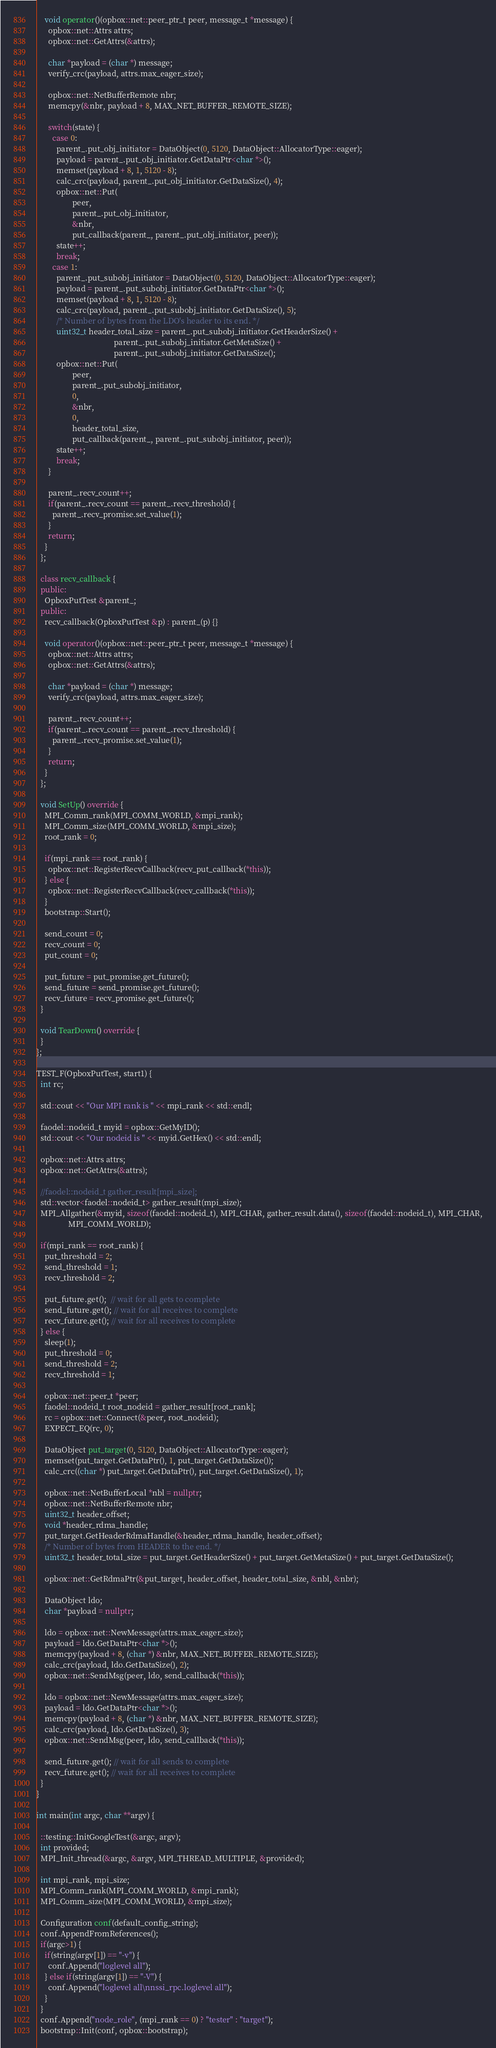<code> <loc_0><loc_0><loc_500><loc_500><_C++_>
    void operator()(opbox::net::peer_ptr_t peer, message_t *message) {
      opbox::net::Attrs attrs;
      opbox::net::GetAttrs(&attrs);

      char *payload = (char *) message;
      verify_crc(payload, attrs.max_eager_size);

      opbox::net::NetBufferRemote nbr;
      memcpy(&nbr, payload + 8, MAX_NET_BUFFER_REMOTE_SIZE);

      switch(state) {
        case 0:
          parent_.put_obj_initiator = DataObject(0, 5120, DataObject::AllocatorType::eager);
          payload = parent_.put_obj_initiator.GetDataPtr<char *>();
          memset(payload + 8, 1, 5120 - 8);
          calc_crc(payload, parent_.put_obj_initiator.GetDataSize(), 4);
          opbox::net::Put(
                  peer,
                  parent_.put_obj_initiator,
                  &nbr,
                  put_callback(parent_, parent_.put_obj_initiator, peer));
          state++;
          break;
        case 1:
          parent_.put_subobj_initiator = DataObject(0, 5120, DataObject::AllocatorType::eager);
          payload = parent_.put_subobj_initiator.GetDataPtr<char *>();
          memset(payload + 8, 1, 5120 - 8);
          calc_crc(payload, parent_.put_subobj_initiator.GetDataSize(), 5);
          /* Number of bytes from the LDO's header to its end. */
          uint32_t header_total_size = parent_.put_subobj_initiator.GetHeaderSize() +
                                       parent_.put_subobj_initiator.GetMetaSize() +
                                       parent_.put_subobj_initiator.GetDataSize();
          opbox::net::Put(
                  peer,
                  parent_.put_subobj_initiator,
                  0,
                  &nbr,
                  0,
                  header_total_size,
                  put_callback(parent_, parent_.put_subobj_initiator, peer));
          state++;
          break;
      }

      parent_.recv_count++;
      if(parent_.recv_count == parent_.recv_threshold) {
        parent_.recv_promise.set_value(1);
      }
      return;
    }
  };

  class recv_callback {
  public:
    OpboxPutTest &parent_;
  public:
    recv_callback(OpboxPutTest &p) : parent_(p) {}

    void operator()(opbox::net::peer_ptr_t peer, message_t *message) {
      opbox::net::Attrs attrs;
      opbox::net::GetAttrs(&attrs);

      char *payload = (char *) message;
      verify_crc(payload, attrs.max_eager_size);

      parent_.recv_count++;
      if(parent_.recv_count == parent_.recv_threshold) {
        parent_.recv_promise.set_value(1);
      }
      return;
    }
  };

  void SetUp() override {
    MPI_Comm_rank(MPI_COMM_WORLD, &mpi_rank);
    MPI_Comm_size(MPI_COMM_WORLD, &mpi_size);
    root_rank = 0;

    if(mpi_rank == root_rank) {
      opbox::net::RegisterRecvCallback(recv_put_callback(*this));
    } else {
      opbox::net::RegisterRecvCallback(recv_callback(*this));
    }
    bootstrap::Start();

    send_count = 0;
    recv_count = 0;
    put_count = 0;

    put_future = put_promise.get_future();
    send_future = send_promise.get_future();
    recv_future = recv_promise.get_future();
  }

  void TearDown() override {
  }
};

TEST_F(OpboxPutTest, start1) {
  int rc;

  std::cout << "Our MPI rank is " << mpi_rank << std::endl;

  faodel::nodeid_t myid = opbox::GetMyID();
  std::cout << "Our nodeid is " << myid.GetHex() << std::endl;

  opbox::net::Attrs attrs;
  opbox::net::GetAttrs(&attrs);

  //faodel::nodeid_t gather_result[mpi_size];
  std::vector<faodel::nodeid_t> gather_result(mpi_size);
  MPI_Allgather(&myid, sizeof(faodel::nodeid_t), MPI_CHAR, gather_result.data(), sizeof(faodel::nodeid_t), MPI_CHAR,
                MPI_COMM_WORLD);

  if(mpi_rank == root_rank) {
    put_threshold = 2;
    send_threshold = 1;
    recv_threshold = 2;

    put_future.get();  // wait for all gets to complete
    send_future.get(); // wait for all receives to complete
    recv_future.get(); // wait for all receives to complete
  } else {
    sleep(1);
    put_threshold = 0;
    send_threshold = 2;
    recv_threshold = 1;

    opbox::net::peer_t *peer;
    faodel::nodeid_t root_nodeid = gather_result[root_rank];
    rc = opbox::net::Connect(&peer, root_nodeid);
    EXPECT_EQ(rc, 0);

    DataObject put_target(0, 5120, DataObject::AllocatorType::eager);
    memset(put_target.GetDataPtr(), 1, put_target.GetDataSize());
    calc_crc((char *) put_target.GetDataPtr(), put_target.GetDataSize(), 1);

    opbox::net::NetBufferLocal *nbl = nullptr;
    opbox::net::NetBufferRemote nbr;
    uint32_t header_offset;
    void *header_rdma_handle;
    put_target.GetHeaderRdmaHandle(&header_rdma_handle, header_offset);
    /* Number of bytes from HEADER to the end. */
    uint32_t header_total_size = put_target.GetHeaderSize() + put_target.GetMetaSize() + put_target.GetDataSize();

    opbox::net::GetRdmaPtr(&put_target, header_offset, header_total_size, &nbl, &nbr);

    DataObject ldo;
    char *payload = nullptr;

    ldo = opbox::net::NewMessage(attrs.max_eager_size);
    payload = ldo.GetDataPtr<char *>();
    memcpy(payload + 8, (char *) &nbr, MAX_NET_BUFFER_REMOTE_SIZE);
    calc_crc(payload, ldo.GetDataSize(), 2);
    opbox::net::SendMsg(peer, ldo, send_callback(*this));

    ldo = opbox::net::NewMessage(attrs.max_eager_size);
    payload = ldo.GetDataPtr<char *>();
    memcpy(payload + 8, (char *) &nbr, MAX_NET_BUFFER_REMOTE_SIZE);
    calc_crc(payload, ldo.GetDataSize(), 3);
    opbox::net::SendMsg(peer, ldo, send_callback(*this));

    send_future.get(); // wait for all sends to complete
    recv_future.get(); // wait for all receives to complete
  }
}

int main(int argc, char **argv) {

  ::testing::InitGoogleTest(&argc, argv);
  int provided;
  MPI_Init_thread(&argc, &argv, MPI_THREAD_MULTIPLE, &provided);

  int mpi_rank, mpi_size;
  MPI_Comm_rank(MPI_COMM_WORLD, &mpi_rank);
  MPI_Comm_size(MPI_COMM_WORLD, &mpi_size);

  Configuration conf(default_config_string);
  conf.AppendFromReferences();
  if(argc>1) {
    if(string(argv[1]) == "-v") {
      conf.Append("loglevel all");
    } else if(string(argv[1]) == "-V") {
      conf.Append("loglevel all\nnssi_rpc.loglevel all");
    }
  }
  conf.Append("node_role", (mpi_rank == 0) ? "tester" : "target");
  bootstrap::Init(conf, opbox::bootstrap);
</code> 